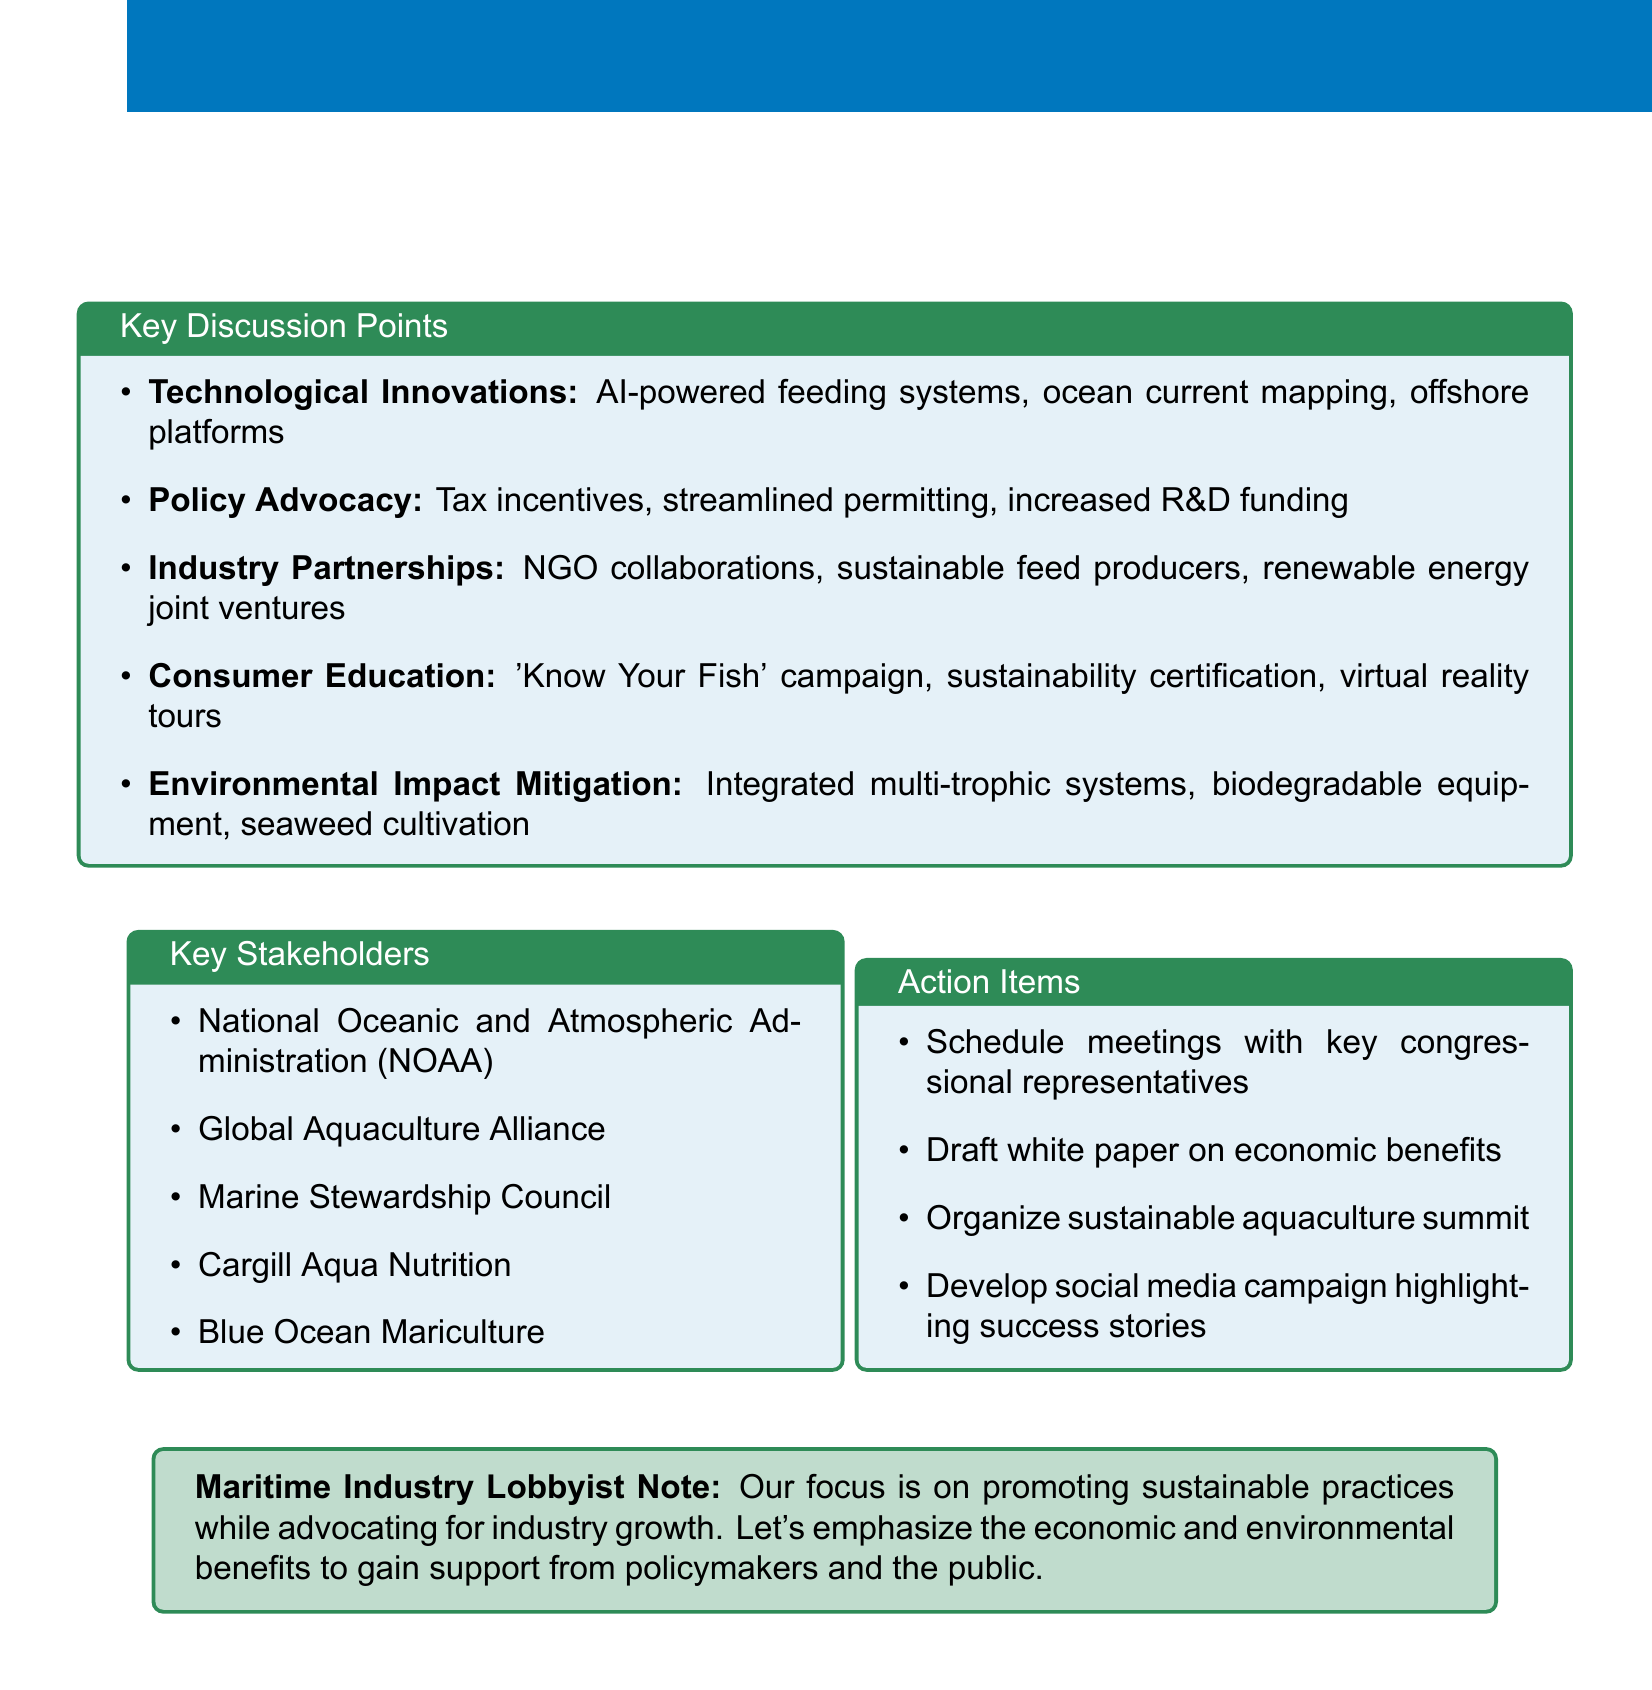What is the title of the session? The title of the session is provided at the beginning of the document.
Answer: Promoting Sustainable Aquaculture Practices: Maritime Industry Strategies What is one technological innovation mentioned? The document lists specific ideas under technological innovations.
Answer: AI-powered feeding systems Who is a key stakeholder mentioned in the document? The document lists several key stakeholders related to sustainable aquaculture practices.
Answer: National Oceanic and Atmospheric Administration (NOAA) What is one proposed action item? The document includes a section on action items that outlines specific initiatives to be taken.
Answer: Schedule meetings with key congressional representatives What is the focus of the maritime industry lobbyist note? The note summarizes the overarching aim related to industry practices and support.
Answer: Promoting sustainable practices while advocating for industry growth How many topics are listed under key discussion points? The document enumerates different discussion points relevant to sustainable aquaculture practices.
Answer: Five 